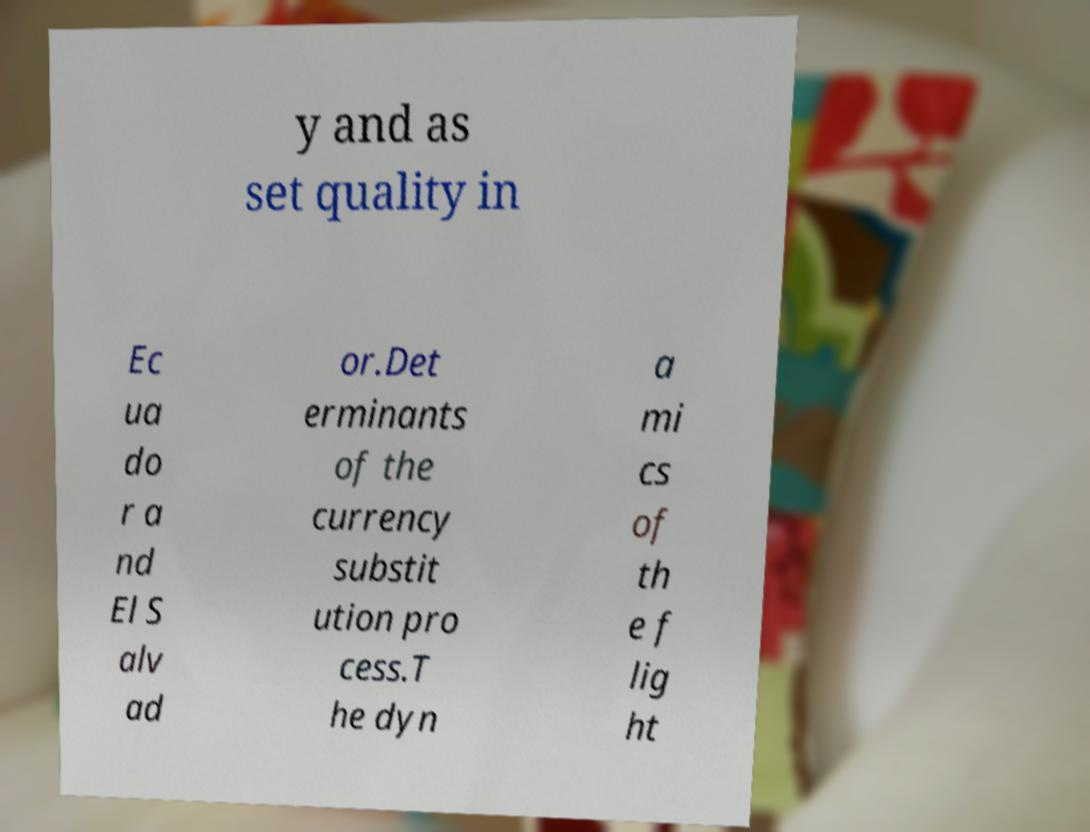Can you accurately transcribe the text from the provided image for me? y and as set quality in Ec ua do r a nd El S alv ad or.Det erminants of the currency substit ution pro cess.T he dyn a mi cs of th e f lig ht 